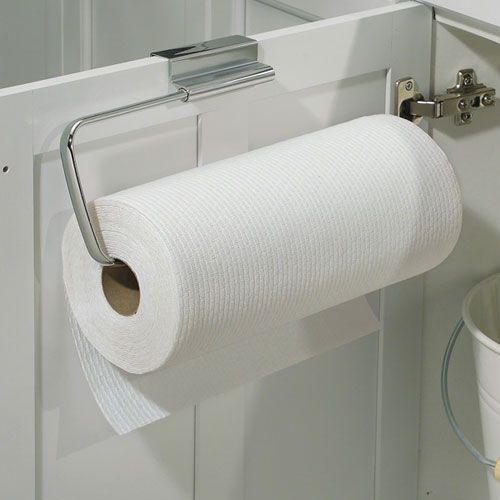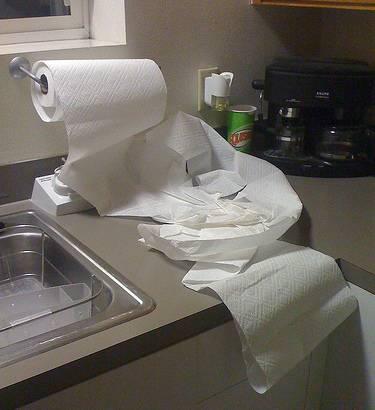The first image is the image on the left, the second image is the image on the right. Assess this claim about the two images: "In one image, a roll of white paper towels in on a chrome rack attached to the inside of a white cabinet door.". Correct or not? Answer yes or no. Yes. The first image is the image on the left, the second image is the image on the right. For the images displayed, is the sentence "An image shows one white towel roll mounted on a bar hung on a cabinet door." factually correct? Answer yes or no. Yes. 